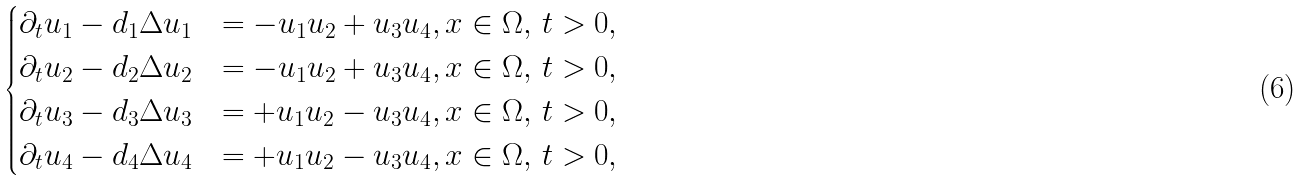Convert formula to latex. <formula><loc_0><loc_0><loc_500><loc_500>\begin{cases} \partial _ { t } u _ { 1 } - d _ { 1 } \Delta u _ { 1 } & = - u _ { 1 } u _ { 2 } + u _ { 3 } u _ { 4 } , x \in \Omega , \, t > 0 , \\ \partial _ { t } u _ { 2 } - d _ { 2 } \Delta u _ { 2 } & = - u _ { 1 } u _ { 2 } + u _ { 3 } u _ { 4 } , x \in \Omega , \, t > 0 , \\ \partial _ { t } u _ { 3 } - d _ { 3 } \Delta u _ { 3 } & = + u _ { 1 } u _ { 2 } - u _ { 3 } u _ { 4 } , x \in \Omega , \, t > 0 , \\ \partial _ { t } u _ { 4 } - d _ { 4 } \Delta u _ { 4 } & = + u _ { 1 } u _ { 2 } - u _ { 3 } u _ { 4 } , x \in \Omega , \, t > 0 , \\ \end{cases}</formula> 